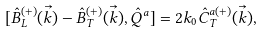<formula> <loc_0><loc_0><loc_500><loc_500>{ [ } \hat { B } ^ { ( + ) } _ { L } ( \vec { k } ) - \hat { B } ^ { ( + ) } _ { T } ( \vec { k } ) , \hat { Q } ^ { a } ] = 2 k _ { 0 } \hat { C } ^ { a ( + ) } _ { T } ( \vec { k } ) ,</formula> 